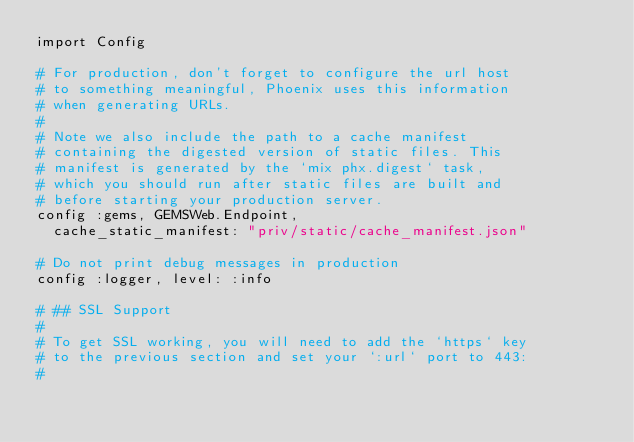Convert code to text. <code><loc_0><loc_0><loc_500><loc_500><_Elixir_>import Config

# For production, don't forget to configure the url host
# to something meaningful, Phoenix uses this information
# when generating URLs.
#
# Note we also include the path to a cache manifest
# containing the digested version of static files. This
# manifest is generated by the `mix phx.digest` task,
# which you should run after static files are built and
# before starting your production server.
config :gems, GEMSWeb.Endpoint,
  cache_static_manifest: "priv/static/cache_manifest.json"

# Do not print debug messages in production
config :logger, level: :info

# ## SSL Support
#
# To get SSL working, you will need to add the `https` key
# to the previous section and set your `:url` port to 443:
#</code> 